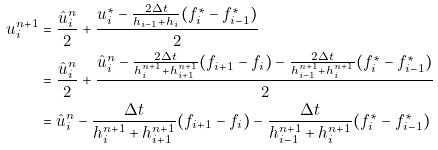<formula> <loc_0><loc_0><loc_500><loc_500>u _ { i } ^ { n + 1 } & = \frac { \hat { u } _ { i } ^ { n } } { 2 } + \frac { u _ { i } ^ { \ast } - \frac { 2 \Delta t } { h _ { i - 1 } + h _ { i } } ( f _ { i } ^ { \ast } - f _ { i - 1 } ^ { \ast } ) } { 2 } \\ & = \frac { \hat { u } _ { i } ^ { n } } { 2 } + \frac { \hat { u } _ { i } ^ { n } - \frac { 2 \Delta t } { h _ { i } ^ { n + 1 } + h _ { i + 1 } ^ { n + 1 } } ( f _ { i + 1 } - f _ { i } ) - \frac { 2 \Delta t } { h _ { i - 1 } ^ { n + 1 } + h _ { i } ^ { n + 1 } } ( f _ { i } ^ { \ast } - f _ { i - 1 } ^ { \ast } ) } { 2 } \\ & = \hat { u } _ { i } ^ { n } - \frac { \Delta t } { h _ { i } ^ { n + 1 } + h _ { i + 1 } ^ { n + 1 } } ( f _ { i + 1 } - f _ { i } ) - \frac { \Delta t } { h _ { i - 1 } ^ { n + 1 } + h _ { i } ^ { n + 1 } } ( f _ { i } ^ { \ast } - f _ { i - 1 } ^ { \ast } )</formula> 